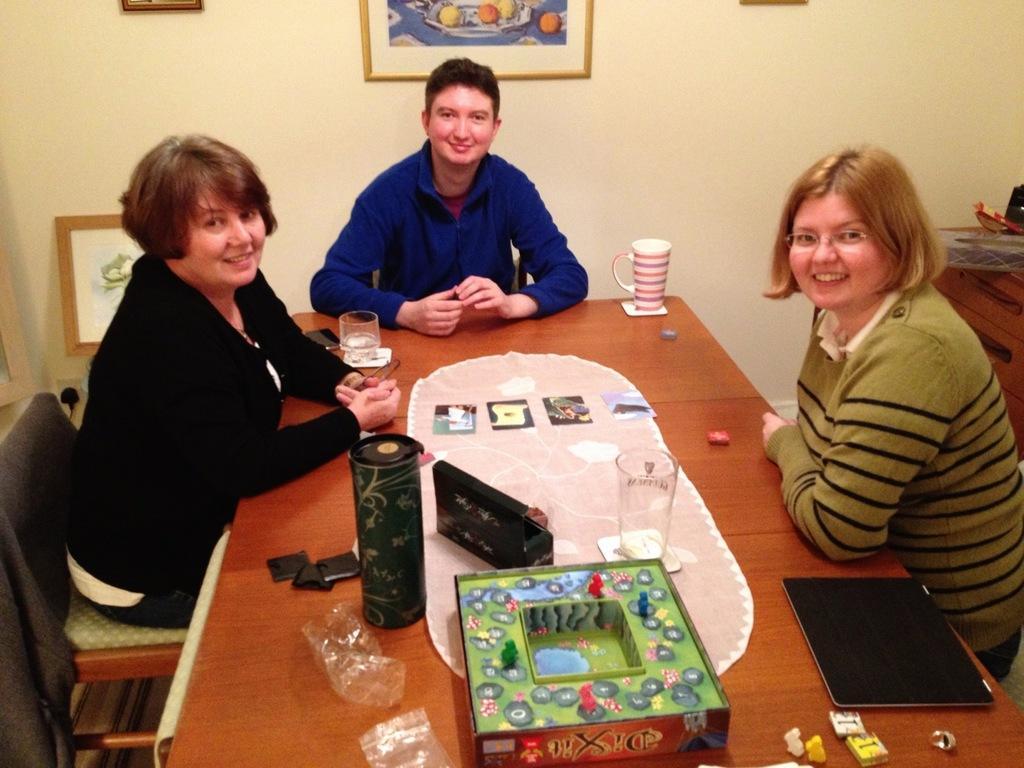How would you summarize this image in a sentence or two? The persons are sitting in a room. There is a table. There is a bottle,laptop,glass and polythene cover on a table. The persons are given a smile. We can see in the background there is a frames and wall. 